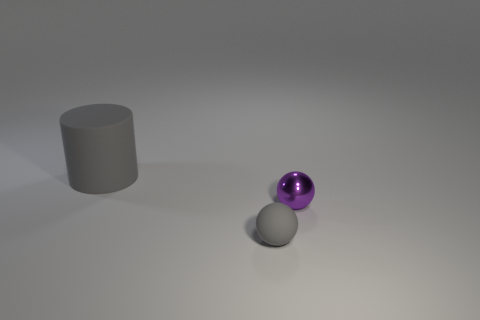What material is the thing that is the same color as the matte cylinder?
Make the answer very short. Rubber. How many other matte balls have the same size as the purple sphere?
Ensure brevity in your answer.  1. There is another thing that is the same color as the tiny rubber thing; what shape is it?
Make the answer very short. Cylinder. There is a matte thing behind the rubber sphere; is it the same color as the sphere to the left of the tiny metal sphere?
Your answer should be very brief. Yes. There is a small gray thing; what number of large rubber objects are to the right of it?
Make the answer very short. 0. There is another rubber thing that is the same color as the large rubber object; what size is it?
Your response must be concise. Small. Are there any large red objects that have the same shape as the small purple metal thing?
Offer a very short reply. No. There is a ball that is the same size as the metal thing; what color is it?
Your answer should be very brief. Gray. Is the number of gray rubber things to the left of the large gray object less than the number of big matte objects that are behind the tiny purple metallic ball?
Offer a very short reply. Yes. Do the object that is to the left of the matte ball and the small gray sphere have the same size?
Offer a terse response. No. 